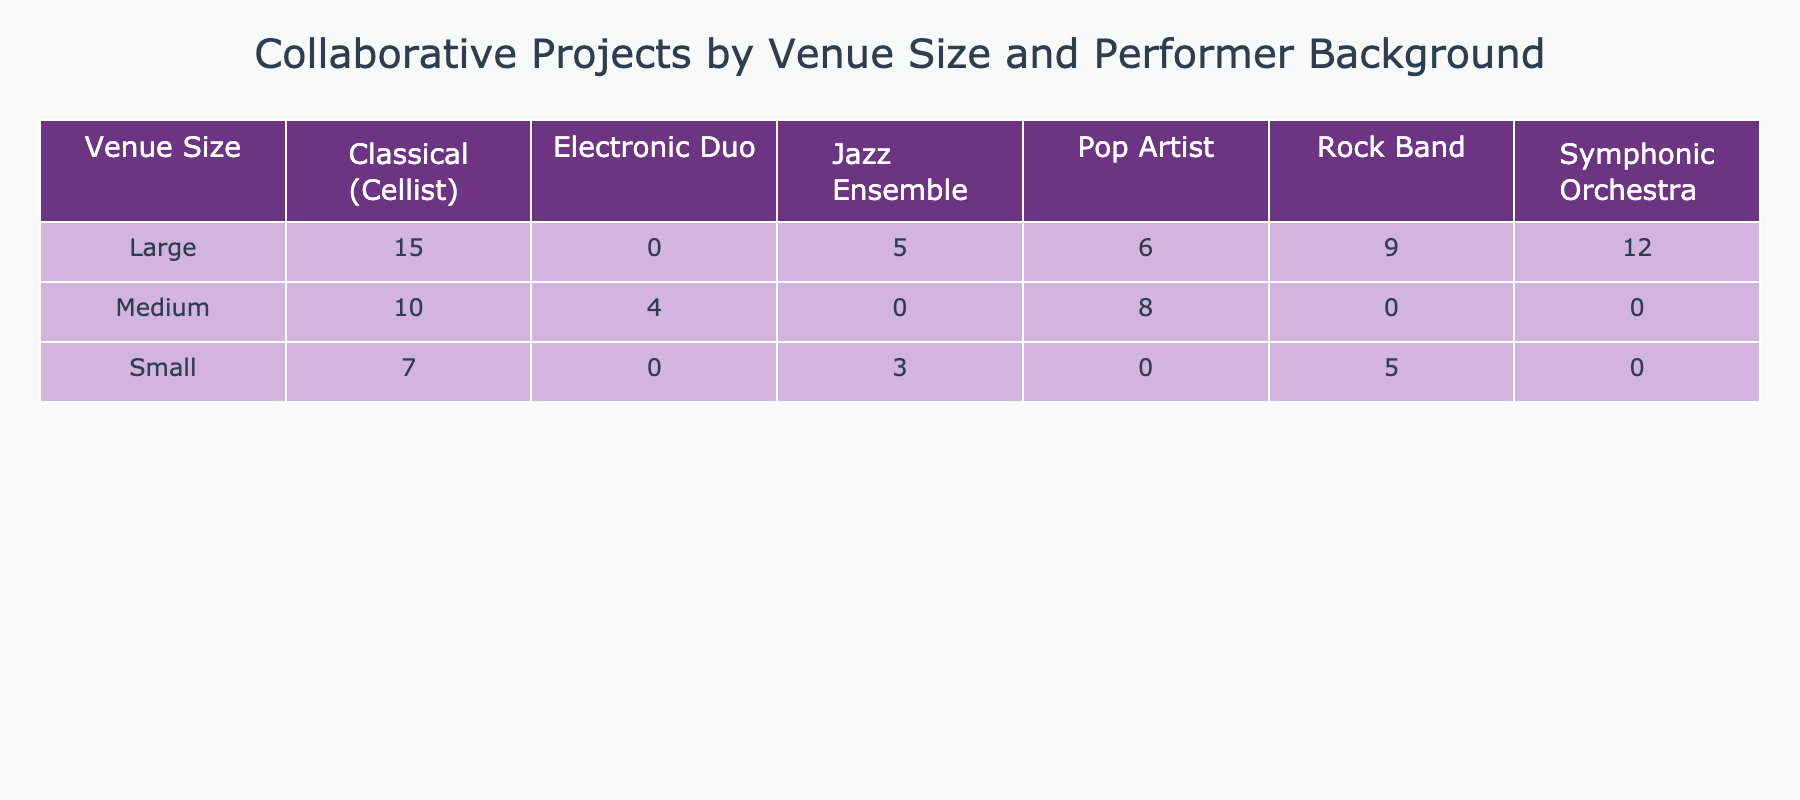What is the highest number of collaborative projects for Classical (Cellist) in Large venues? The table shows the number of collaborative projects for each performer background across venue sizes. For Classical (Cellist) in Large venues, the value is 15, which is the highest recorded for this background.
Answer: 15 How many collaborative projects were there for Jazz Ensembles across all venue sizes? To find this, we look at the number of collaborative projects for Jazz Ensemble under each venue size: Small has 3, Medium has 0, and Large has 5. Adding these, we get 3 + 0 + 5 = 8.
Answer: 8 Is there any venue size that has more than 10 collaborations for a Rock Band? Looking at the table, we see Rock Band has 5 in Small, 9 in Large, and no entries for Medium. None of these values exceed 10, indicating that no venue size has more than 10 collaborations.
Answer: No What is the total number of collaborative projects for Medium-sized venues? We examine the table for Medium venue sizes, where there are 10 for Classical (Cellist), 8 for Pop Artist, and 4 for Electronic Duo. Adding these values gives us 10 + 8 + 4 = 22 for Medium-sized venues.
Answer: 22 Which performer background has the second highest number of collaborative projects in Large venues? In the Large venues category, Classical (Cellist) has 15, Symphonic Orchestra has 12, Rock Band has 9, and others have lower values. Therefore, the second highest is Symphonic Orchestra with 12 collaborations.
Answer: Symphonic Orchestra What is the difference in the number of collaborative projects between Classical (Cellist) in Medium and Small venues? In the table, we see that for Classical (Cellist), there are 10 projects in Medium venues and 7 in Small venues. We calculate the difference: 10 - 7 = 3.
Answer: 3 Is the number of collaborative projects for Electronic Duo greater than those for Jazz Ensemble in Medium venues? There are 0 collaborative projects for Jazz Ensemble in Medium venues since it is not listed, while Electronic Duo has 4. Since 4 > 0, the answer is yes.
Answer: Yes How many more collaborative projects are there for Classical (Cellist) in Large than in Small venues? Looking at the counts for Classical (Cellist), we have 15 in Large venues and 7 in Small venues. The difference is 15 - 7 = 8, meaning there are 8 more projects in Large venues.
Answer: 8 What is the average number of collaborative projects for Rock Band across all venue sizes? For Rock Band, we have 5 in Small, 9 in Large, and 0 in Medium venues. We sum these values: 5 + 9 + 0 = 14 and then divide by 3 (the number of entries) to find the average: 14 / 3 = 4.67.
Answer: 4.67 